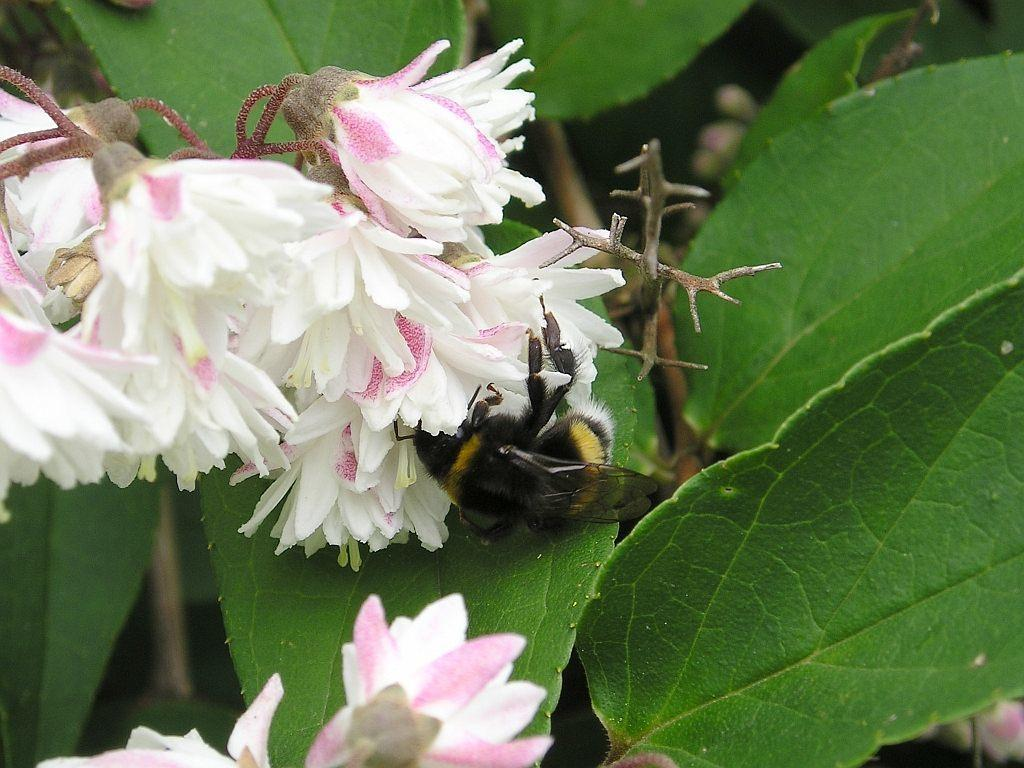What is present in the image? There is a fly in the image. Can you describe the fly's location? The fly is on a flower. What type of stamp can be seen on the dinosaur in the image? There are no dinosaurs or stamps present in the image; it features a fly on a flower. 